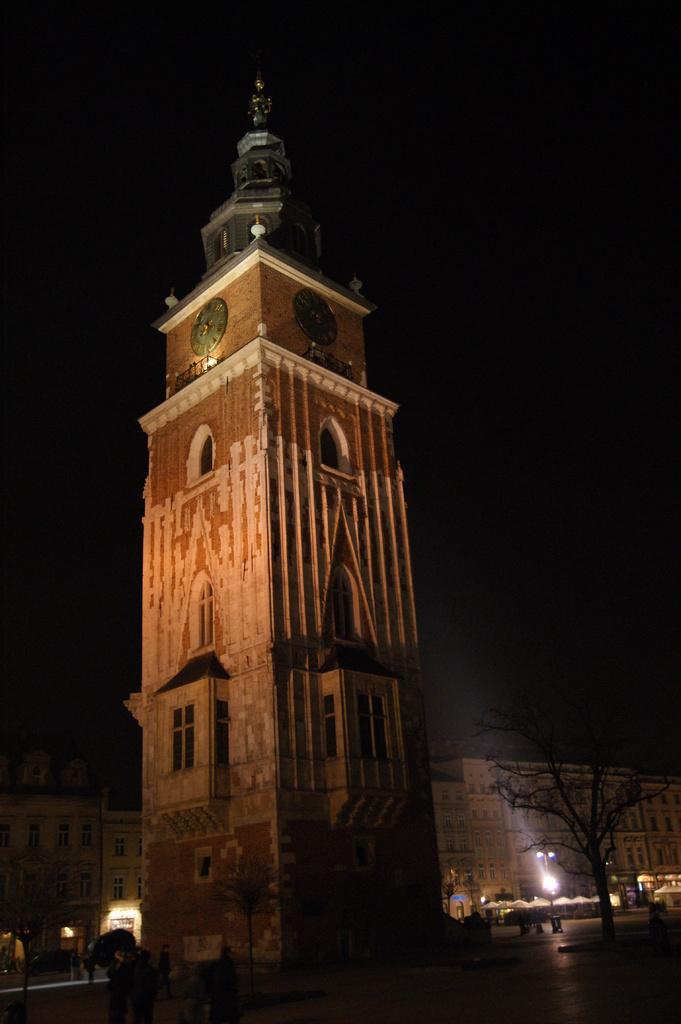How would you summarize this image in a sentence or two? Here we can see buildings, clocks, trees, lights, and few persons. In the background there is sky. 